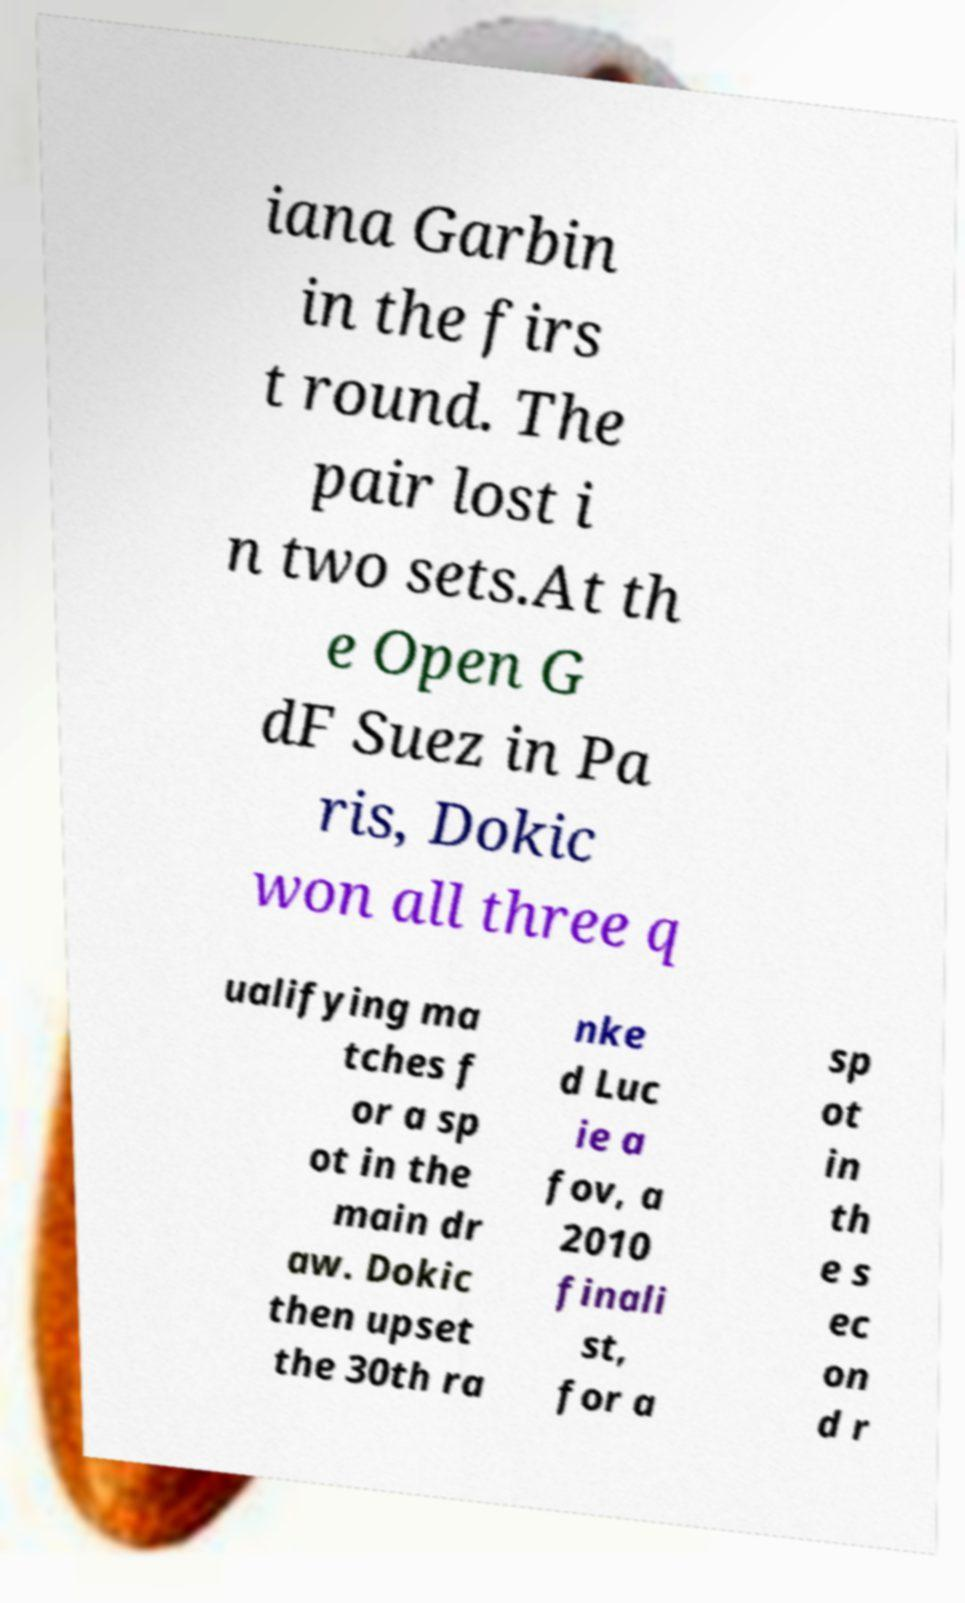I need the written content from this picture converted into text. Can you do that? iana Garbin in the firs t round. The pair lost i n two sets.At th e Open G dF Suez in Pa ris, Dokic won all three q ualifying ma tches f or a sp ot in the main dr aw. Dokic then upset the 30th ra nke d Luc ie a fov, a 2010 finali st, for a sp ot in th e s ec on d r 